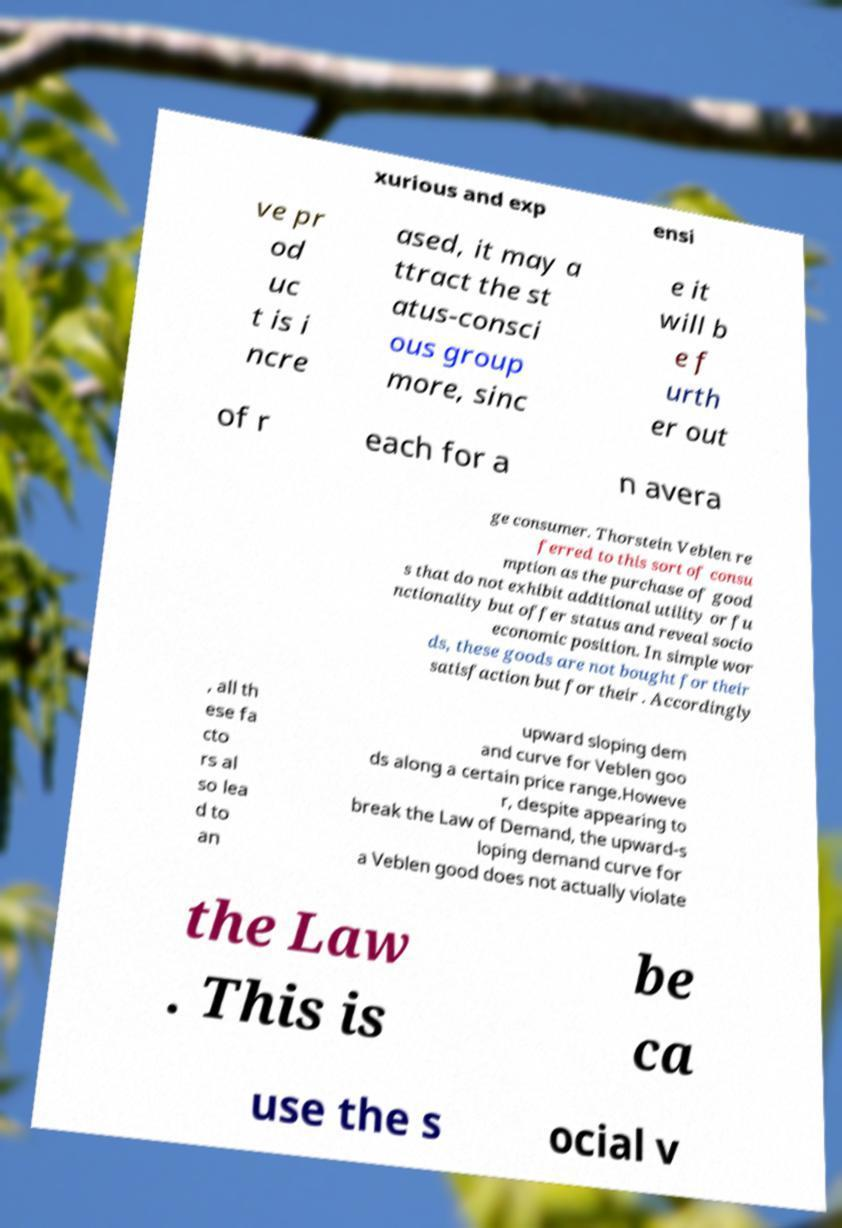Could you extract and type out the text from this image? xurious and exp ensi ve pr od uc t is i ncre ased, it may a ttract the st atus-consci ous group more, sinc e it will b e f urth er out of r each for a n avera ge consumer. Thorstein Veblen re ferred to this sort of consu mption as the purchase of good s that do not exhibit additional utility or fu nctionality but offer status and reveal socio economic position. In simple wor ds, these goods are not bought for their satisfaction but for their . Accordingly , all th ese fa cto rs al so lea d to an upward sloping dem and curve for Veblen goo ds along a certain price range.Howeve r, despite appearing to break the Law of Demand, the upward-s loping demand curve for a Veblen good does not actually violate the Law . This is be ca use the s ocial v 